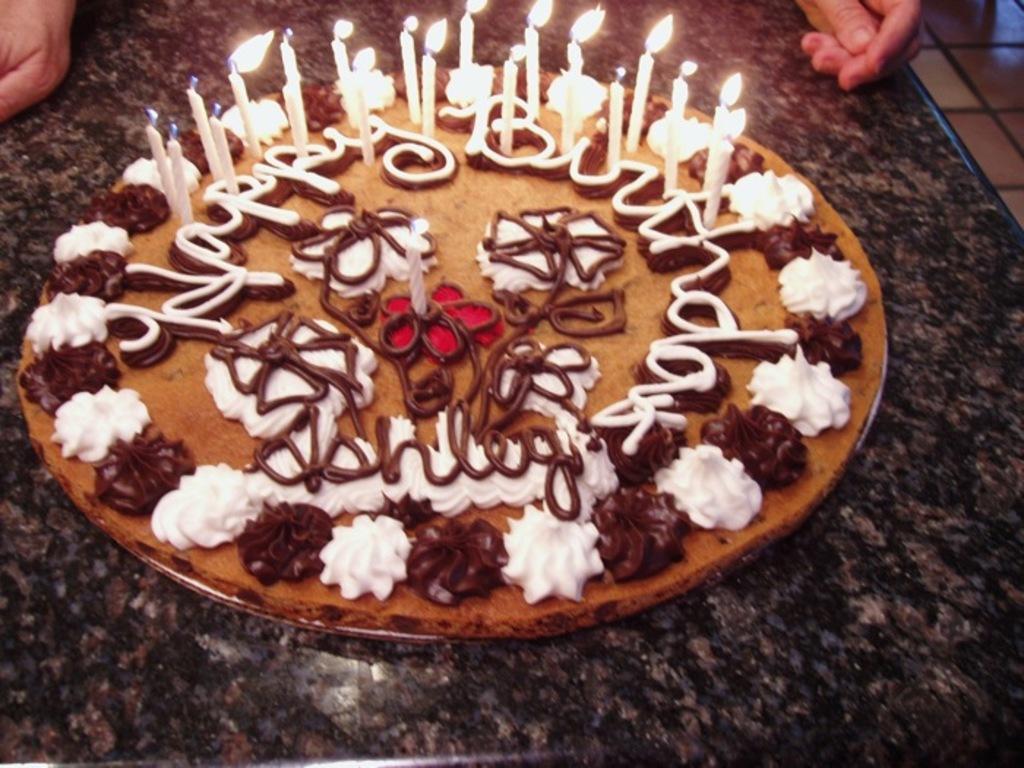Can you describe this image briefly? In the center of the image we can see a cake with group of candles placed on countertop. In the background, we can see the hands of a person. 